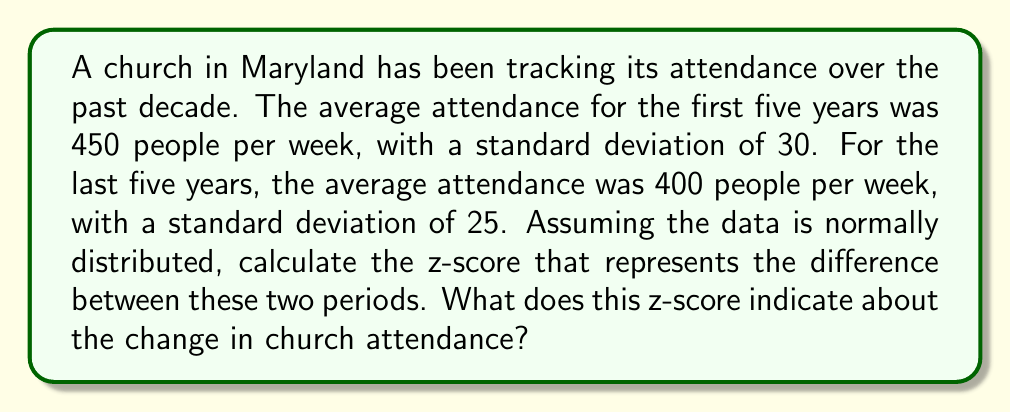What is the answer to this math problem? To solve this problem, we'll follow these steps:

1. Identify the relevant information:
   - First 5 years: $\mu_1 = 450$, $\sigma_1 = 30$
   - Last 5 years: $\mu_2 = 400$, $\sigma_2 = 25$

2. Calculate the difference between the means:
   $\Delta\mu = \mu_1 - \mu_2 = 450 - 400 = 50$

3. Calculate the standard error of the difference between means:
   $SE = \sqrt{\frac{\sigma_1^2}{n_1} + \frac{\sigma_2^2}{n_2}}$
   
   Since we don't have the sample sizes, we'll assume they're equal and large enough to use the population standard deviations:
   
   $SE = \sqrt{\sigma_1^2 + \sigma_2^2} = \sqrt{30^2 + 25^2} = \sqrt{900 + 625} = \sqrt{1525} \approx 39.05$

4. Calculate the z-score:
   $z = \frac{\Delta\mu}{SE} = \frac{50}{39.05} \approx 1.28$

5. Interpret the z-score:
   A z-score of 1.28 indicates that the difference in attendance between the two periods is 1.28 standard deviations above the mean difference we would expect if there were no real change. This suggests a noticeable decrease in attendance over the decade, as the more recent period has a lower average attendance.

   In terms of probability, a z-score of 1.28 corresponds to approximately 90% of the area under the normal curve. This means that if there were no real change in attendance, we would expect to see a difference this large or larger only about 10% of the time by chance.
Answer: $z \approx 1.28$, indicating a significant decrease in attendance 